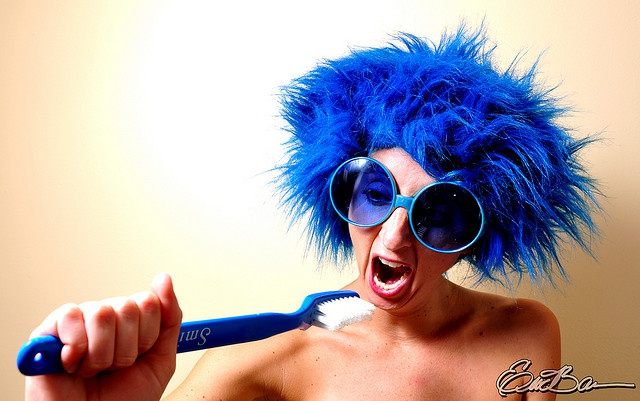Describe the objects in this image and their specific colors. I can see people in tan, maroon, black, blue, and darkblue tones and toothbrush in tan, navy, maroon, white, and brown tones in this image. 